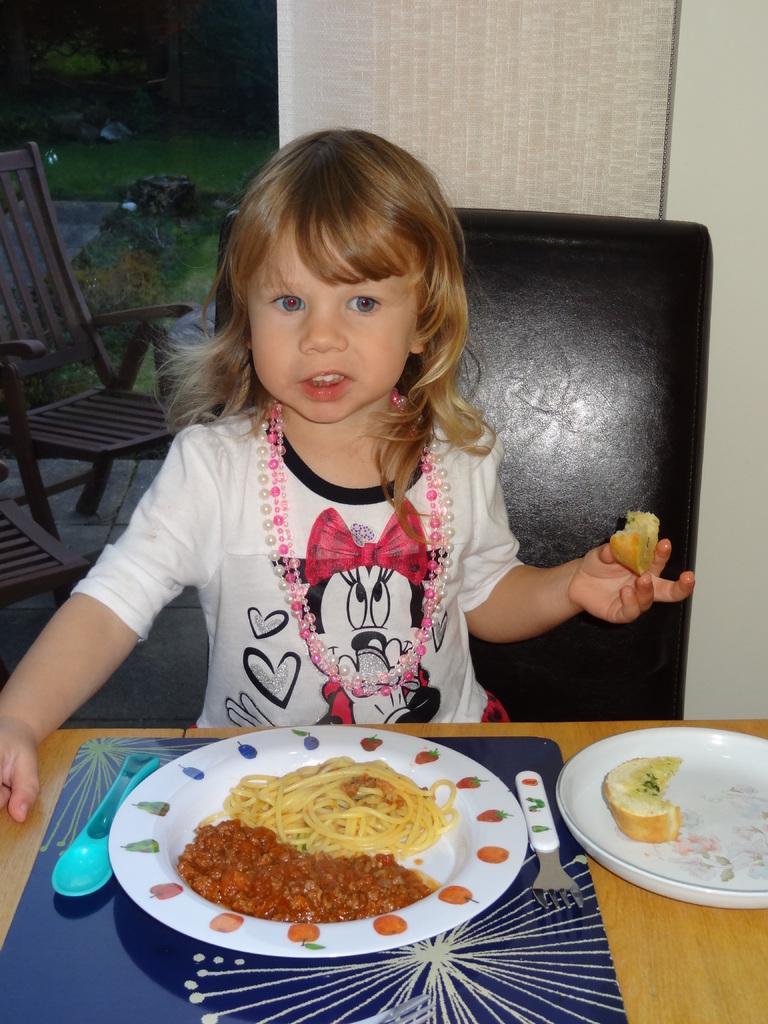Can you describe this image briefly? At the bottom of the image there is a table, on the table there are some plates, fork, spoon and food. Behind the table a girl is sitting and holding food. Behind her there is a wall and there are some chairs. 